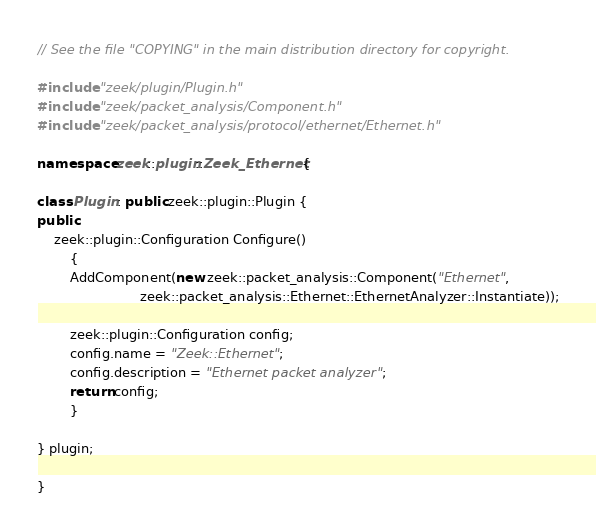Convert code to text. <code><loc_0><loc_0><loc_500><loc_500><_C++_>// See the file "COPYING" in the main distribution directory for copyright.

#include "zeek/plugin/Plugin.h"
#include "zeek/packet_analysis/Component.h"
#include "zeek/packet_analysis/protocol/ethernet/Ethernet.h"

namespace zeek::plugin::Zeek_Ethernet {

class Plugin : public zeek::plugin::Plugin {
public:
	zeek::plugin::Configuration Configure()
		{
		AddComponent(new zeek::packet_analysis::Component("Ethernet",
		                 zeek::packet_analysis::Ethernet::EthernetAnalyzer::Instantiate));

		zeek::plugin::Configuration config;
		config.name = "Zeek::Ethernet";
		config.description = "Ethernet packet analyzer";
		return config;
		}

} plugin;

}
</code> 